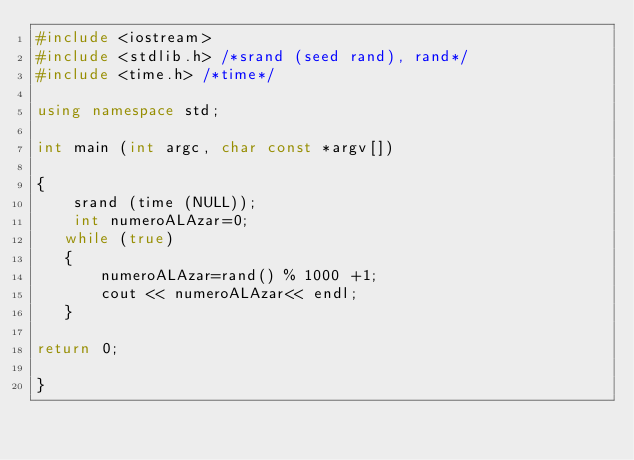Convert code to text. <code><loc_0><loc_0><loc_500><loc_500><_C++_>#include <iostream>
#include <stdlib.h> /*srand (seed rand), rand*/
#include <time.h> /*time*/

using namespace std;

int main (int argc, char const *argv[])

{
    srand (time (NULL));
    int numeroALAzar=0;
   while (true)
   {
       numeroALAzar=rand() % 1000 +1;
       cout << numeroALAzar<< endl;
   }

return 0;

}</code> 